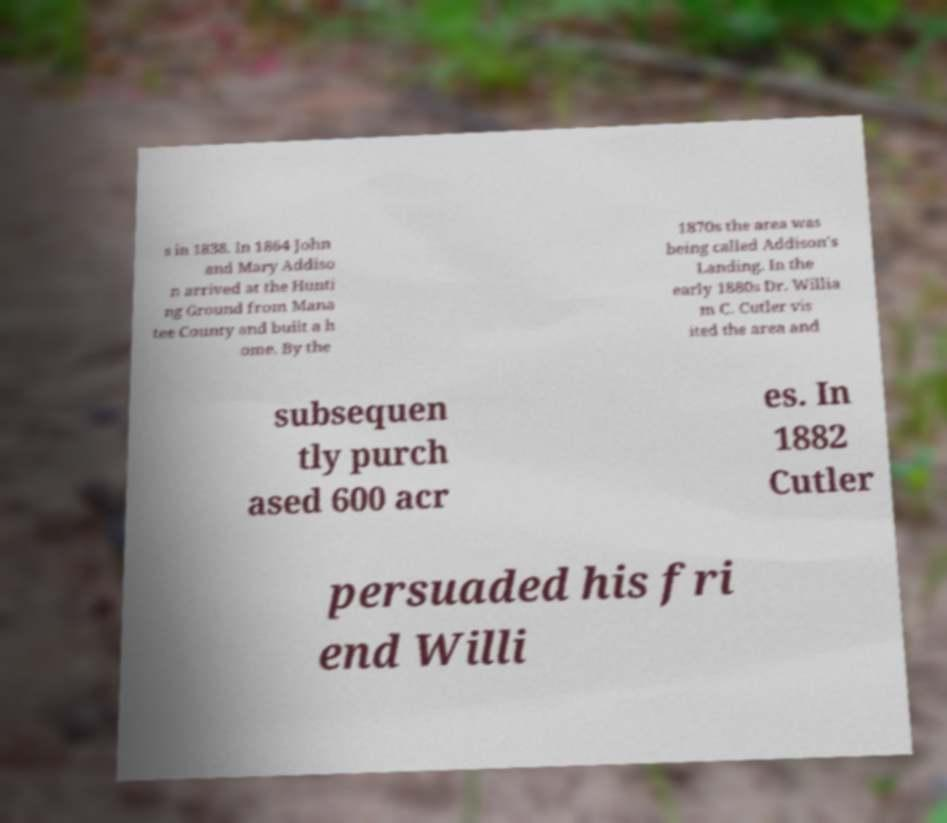Can you read and provide the text displayed in the image?This photo seems to have some interesting text. Can you extract and type it out for me? s in 1838. In 1864 John and Mary Addiso n arrived at the Hunti ng Ground from Mana tee County and built a h ome. By the 1870s the area was being called Addison's Landing. In the early 1880s Dr. Willia m C. Cutler vis ited the area and subsequen tly purch ased 600 acr es. In 1882 Cutler persuaded his fri end Willi 